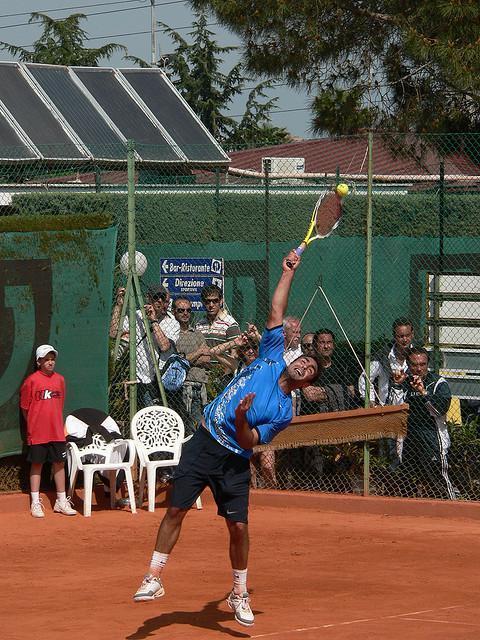How many chairs are there?
Give a very brief answer. 2. How many people are in the picture?
Give a very brief answer. 7. 